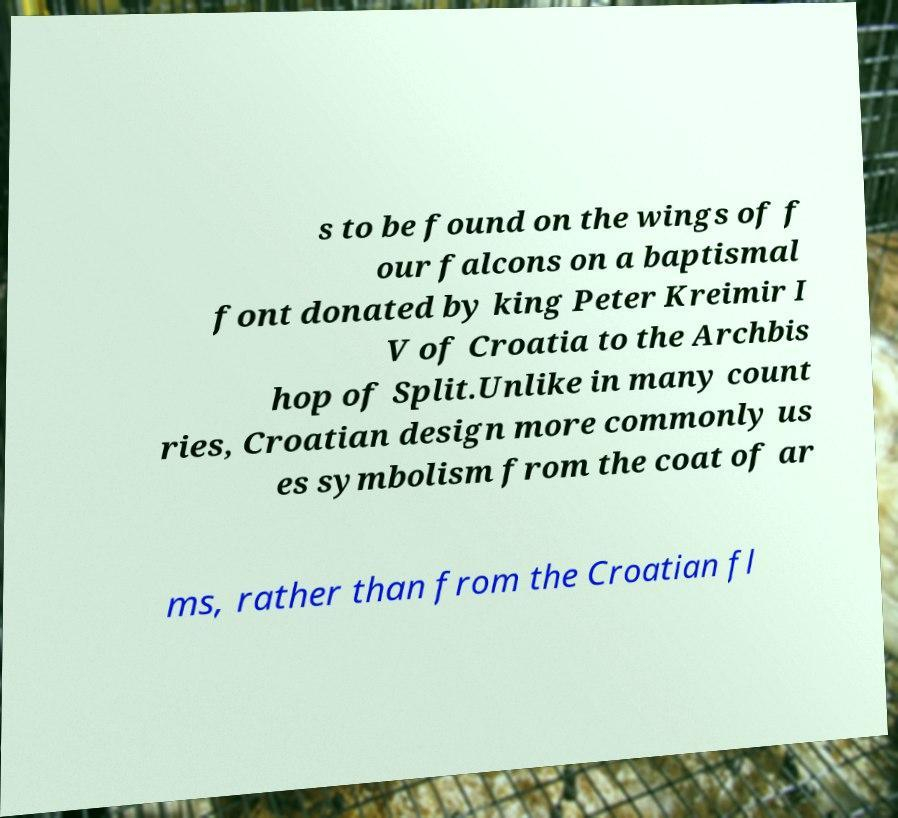There's text embedded in this image that I need extracted. Can you transcribe it verbatim? s to be found on the wings of f our falcons on a baptismal font donated by king Peter Kreimir I V of Croatia to the Archbis hop of Split.Unlike in many count ries, Croatian design more commonly us es symbolism from the coat of ar ms, rather than from the Croatian fl 